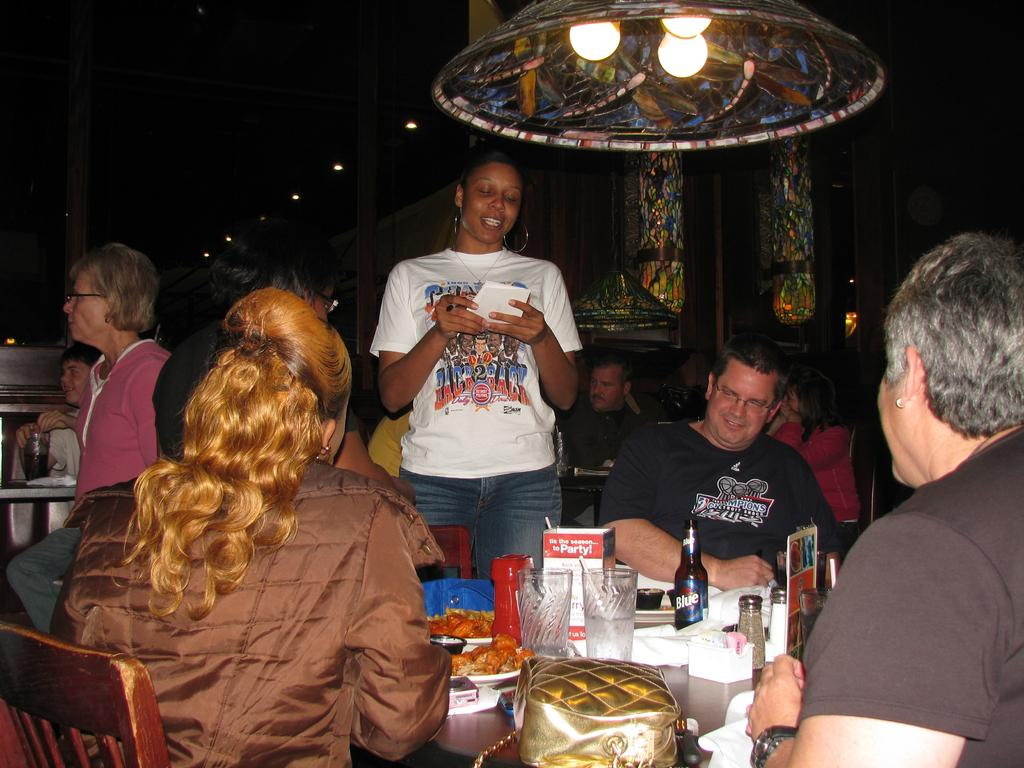How many people are in the image? There is a group of people in the image. What objects are on the table in the image? There are bottles, plates, food, and bags on the table. What can be seen at the top of the image? There are lights visible at the top of the image. Is there a swing visible in the image? No, there is no swing present in the image. 